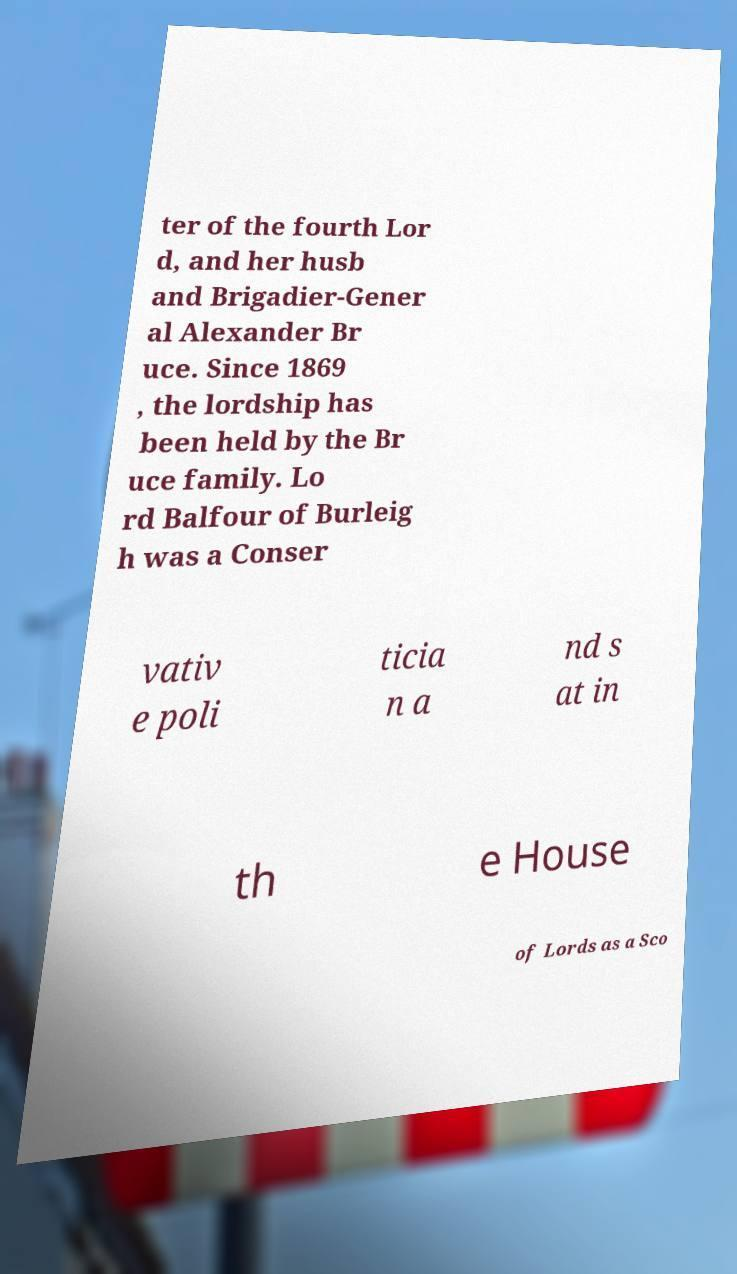Can you read and provide the text displayed in the image?This photo seems to have some interesting text. Can you extract and type it out for me? ter of the fourth Lor d, and her husb and Brigadier-Gener al Alexander Br uce. Since 1869 , the lordship has been held by the Br uce family. Lo rd Balfour of Burleig h was a Conser vativ e poli ticia n a nd s at in th e House of Lords as a Sco 